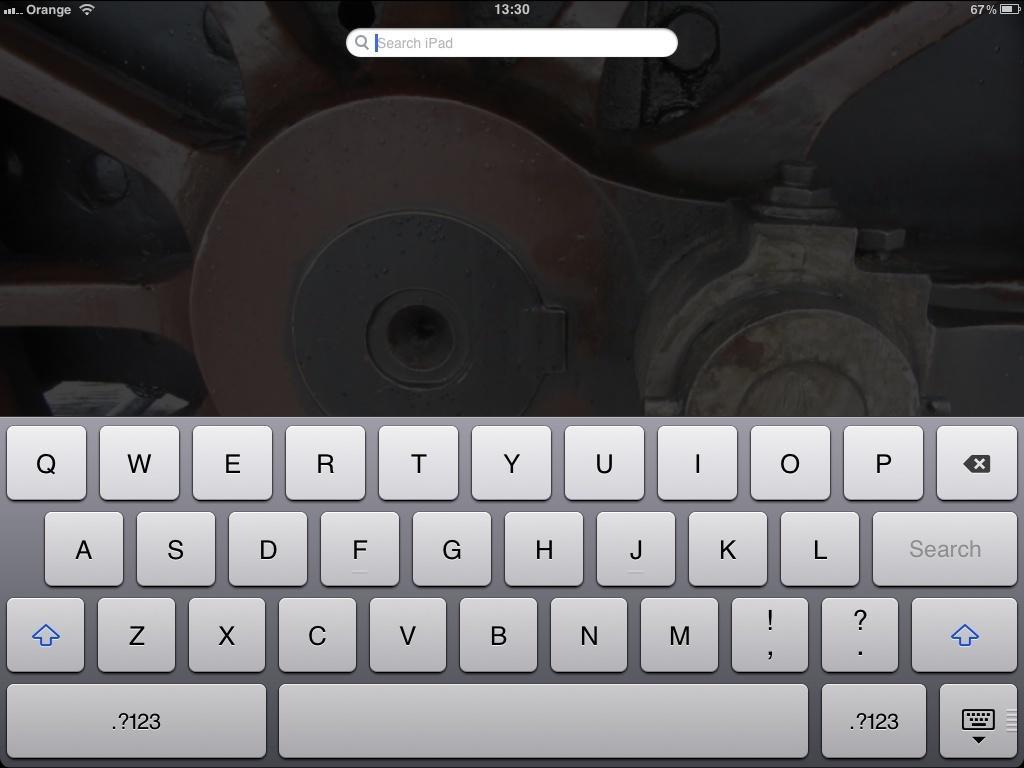Can you describe this image briefly? The image is of a screen. On the screen there is keyboard, search bar. 